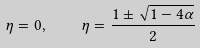Convert formula to latex. <formula><loc_0><loc_0><loc_500><loc_500>\eta = 0 , \quad \eta = \frac { 1 \pm \sqrt { 1 - 4 \alpha } } { 2 }</formula> 